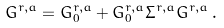<formula> <loc_0><loc_0><loc_500><loc_500>G ^ { r , a } = G ^ { r , a } _ { 0 } + G ^ { r , a } _ { 0 } \Sigma ^ { r , a } G ^ { r , a } \, .</formula> 